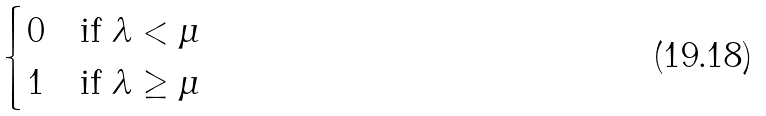Convert formula to latex. <formula><loc_0><loc_0><loc_500><loc_500>\begin{cases} 0 & \text {if $\lambda < \mu$} \\ 1 & \text {if $\lambda \geq \mu$} \end{cases}</formula> 